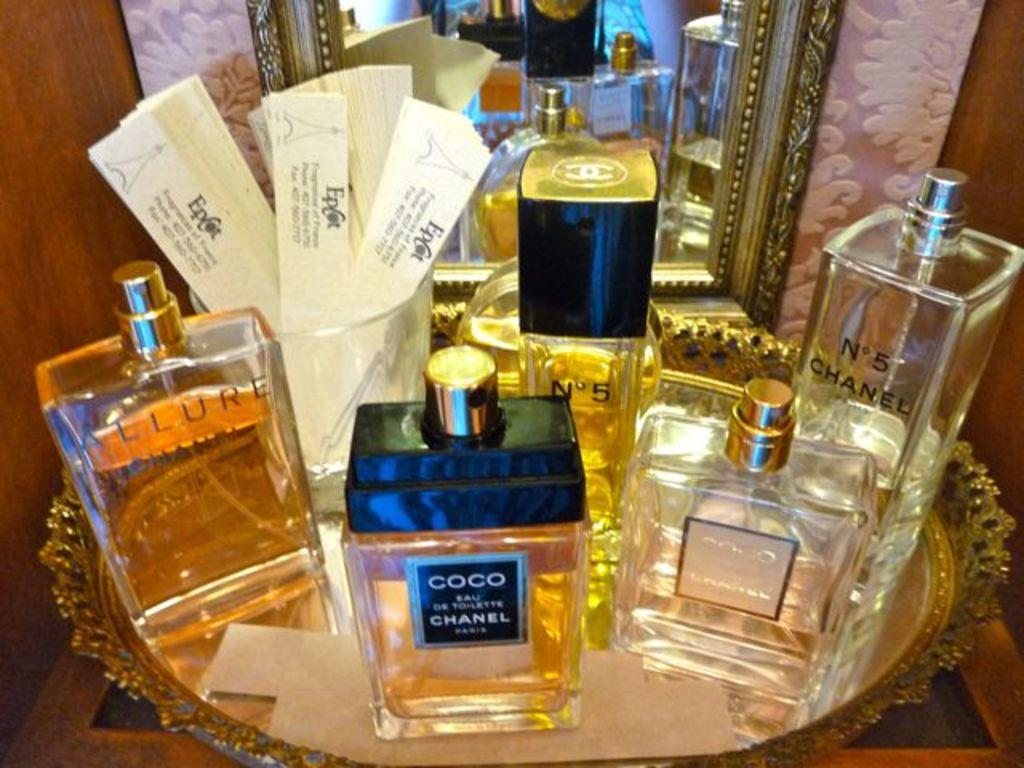Provide a one-sentence caption for the provided image. a selection of perfumes, including coco chanel and n0 5 by chanel. 